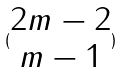<formula> <loc_0><loc_0><loc_500><loc_500>( \begin{matrix} 2 m - 2 \\ m - 1 \end{matrix} )</formula> 